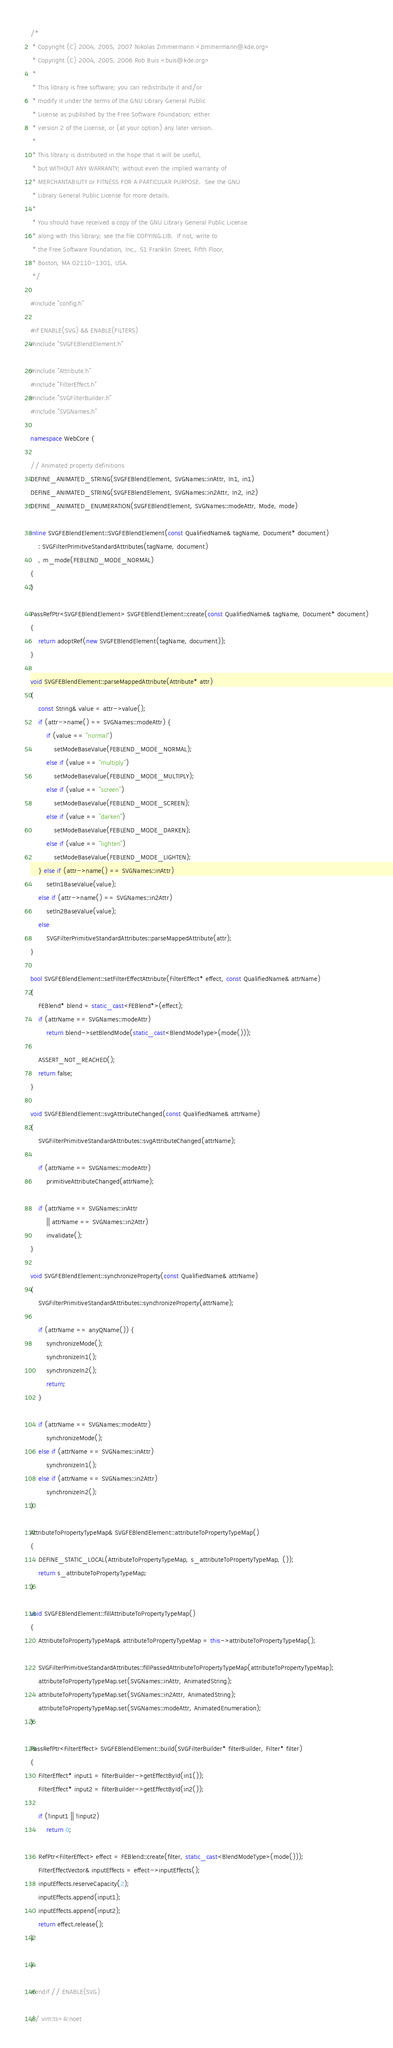Convert code to text. <code><loc_0><loc_0><loc_500><loc_500><_C++_>/*
 * Copyright (C) 2004, 2005, 2007 Nikolas Zimmermann <zimmermann@kde.org>
 * Copyright (C) 2004, 2005, 2006 Rob Buis <buis@kde.org>
 *
 * This library is free software; you can redistribute it and/or
 * modify it under the terms of the GNU Library General Public
 * License as published by the Free Software Foundation; either
 * version 2 of the License, or (at your option) any later version.
 *
 * This library is distributed in the hope that it will be useful,
 * but WITHOUT ANY WARRANTY; without even the implied warranty of
 * MERCHANTABILITY or FITNESS FOR A PARTICULAR PURPOSE.  See the GNU
 * Library General Public License for more details.
 *
 * You should have received a copy of the GNU Library General Public License
 * along with this library; see the file COPYING.LIB.  If not, write to
 * the Free Software Foundation, Inc., 51 Franklin Street, Fifth Floor,
 * Boston, MA 02110-1301, USA.
 */

#include "config.h"

#if ENABLE(SVG) && ENABLE(FILTERS)
#include "SVGFEBlendElement.h"

#include "Attribute.h"
#include "FilterEffect.h"
#include "SVGFilterBuilder.h"
#include "SVGNames.h"

namespace WebCore {

// Animated property definitions
DEFINE_ANIMATED_STRING(SVGFEBlendElement, SVGNames::inAttr, In1, in1)
DEFINE_ANIMATED_STRING(SVGFEBlendElement, SVGNames::in2Attr, In2, in2)
DEFINE_ANIMATED_ENUMERATION(SVGFEBlendElement, SVGNames::modeAttr, Mode, mode)

inline SVGFEBlendElement::SVGFEBlendElement(const QualifiedName& tagName, Document* document)
    : SVGFilterPrimitiveStandardAttributes(tagName, document)
    , m_mode(FEBLEND_MODE_NORMAL)
{
}

PassRefPtr<SVGFEBlendElement> SVGFEBlendElement::create(const QualifiedName& tagName, Document* document)
{
    return adoptRef(new SVGFEBlendElement(tagName, document));
}

void SVGFEBlendElement::parseMappedAttribute(Attribute* attr)
{
    const String& value = attr->value();
    if (attr->name() == SVGNames::modeAttr) {
        if (value == "normal")
            setModeBaseValue(FEBLEND_MODE_NORMAL);
        else if (value == "multiply")
            setModeBaseValue(FEBLEND_MODE_MULTIPLY);
        else if (value == "screen")
            setModeBaseValue(FEBLEND_MODE_SCREEN);
        else if (value == "darken")
            setModeBaseValue(FEBLEND_MODE_DARKEN);
        else if (value == "lighten")
            setModeBaseValue(FEBLEND_MODE_LIGHTEN);
    } else if (attr->name() == SVGNames::inAttr)
        setIn1BaseValue(value);
    else if (attr->name() == SVGNames::in2Attr)
        setIn2BaseValue(value);
    else
        SVGFilterPrimitiveStandardAttributes::parseMappedAttribute(attr);
}

bool SVGFEBlendElement::setFilterEffectAttribute(FilterEffect* effect, const QualifiedName& attrName)
{
    FEBlend* blend = static_cast<FEBlend*>(effect);
    if (attrName == SVGNames::modeAttr)
        return blend->setBlendMode(static_cast<BlendModeType>(mode()));

    ASSERT_NOT_REACHED();
    return false;
}

void SVGFEBlendElement::svgAttributeChanged(const QualifiedName& attrName)
{
    SVGFilterPrimitiveStandardAttributes::svgAttributeChanged(attrName);

    if (attrName == SVGNames::modeAttr)
        primitiveAttributeChanged(attrName);

    if (attrName == SVGNames::inAttr
        || attrName == SVGNames::in2Attr)
        invalidate();
}

void SVGFEBlendElement::synchronizeProperty(const QualifiedName& attrName)
{
    SVGFilterPrimitiveStandardAttributes::synchronizeProperty(attrName);

    if (attrName == anyQName()) {
        synchronizeMode();
        synchronizeIn1();
        synchronizeIn2();
        return;
    }

    if (attrName == SVGNames::modeAttr)
        synchronizeMode();
    else if (attrName == SVGNames::inAttr)
        synchronizeIn1();
    else if (attrName == SVGNames::in2Attr)
        synchronizeIn2();
}

AttributeToPropertyTypeMap& SVGFEBlendElement::attributeToPropertyTypeMap()
{
    DEFINE_STATIC_LOCAL(AttributeToPropertyTypeMap, s_attributeToPropertyTypeMap, ());
    return s_attributeToPropertyTypeMap;
}

void SVGFEBlendElement::fillAttributeToPropertyTypeMap()
{
    AttributeToPropertyTypeMap& attributeToPropertyTypeMap = this->attributeToPropertyTypeMap();

    SVGFilterPrimitiveStandardAttributes::fillPassedAttributeToPropertyTypeMap(attributeToPropertyTypeMap);    
    attributeToPropertyTypeMap.set(SVGNames::inAttr, AnimatedString);
    attributeToPropertyTypeMap.set(SVGNames::in2Attr, AnimatedString);
    attributeToPropertyTypeMap.set(SVGNames::modeAttr, AnimatedEnumeration);
}

PassRefPtr<FilterEffect> SVGFEBlendElement::build(SVGFilterBuilder* filterBuilder, Filter* filter)
{
    FilterEffect* input1 = filterBuilder->getEffectById(in1());
    FilterEffect* input2 = filterBuilder->getEffectById(in2());

    if (!input1 || !input2)
        return 0;

    RefPtr<FilterEffect> effect = FEBlend::create(filter, static_cast<BlendModeType>(mode()));
    FilterEffectVector& inputEffects = effect->inputEffects();
    inputEffects.reserveCapacity(2);
    inputEffects.append(input1);
    inputEffects.append(input2);    
    return effect.release();
}

}

#endif // ENABLE(SVG)

// vim:ts=4:noet
</code> 